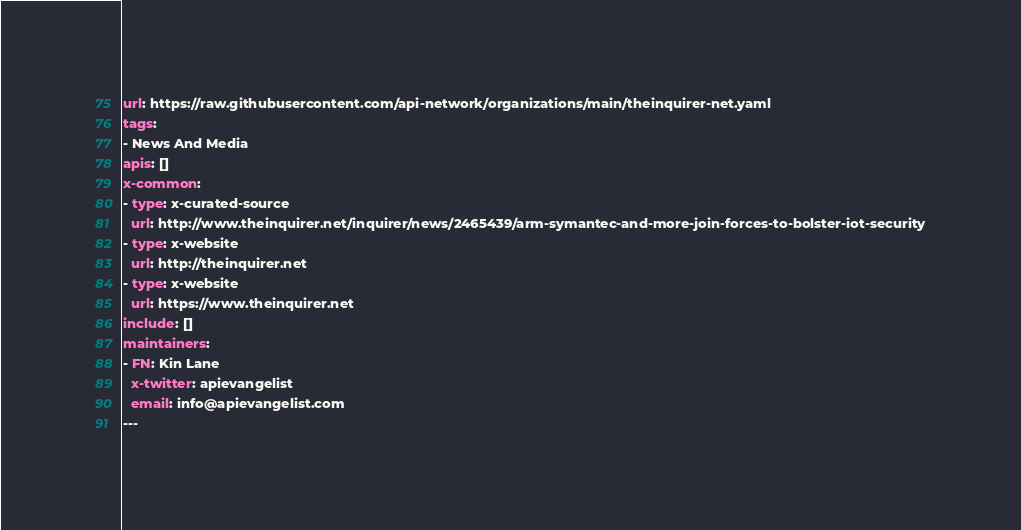Convert code to text. <code><loc_0><loc_0><loc_500><loc_500><_YAML_>url: https://raw.githubusercontent.com/api-network/organizations/main/theinquirer-net.yaml
tags:
- News And Media
apis: []
x-common:
- type: x-curated-source
  url: http://www.theinquirer.net/inquirer/news/2465439/arm-symantec-and-more-join-forces-to-bolster-iot-security
- type: x-website
  url: http://theinquirer.net
- type: x-website
  url: https://www.theinquirer.net
include: []
maintainers:
- FN: Kin Lane
  x-twitter: apievangelist
  email: info@apievangelist.com
---</code> 